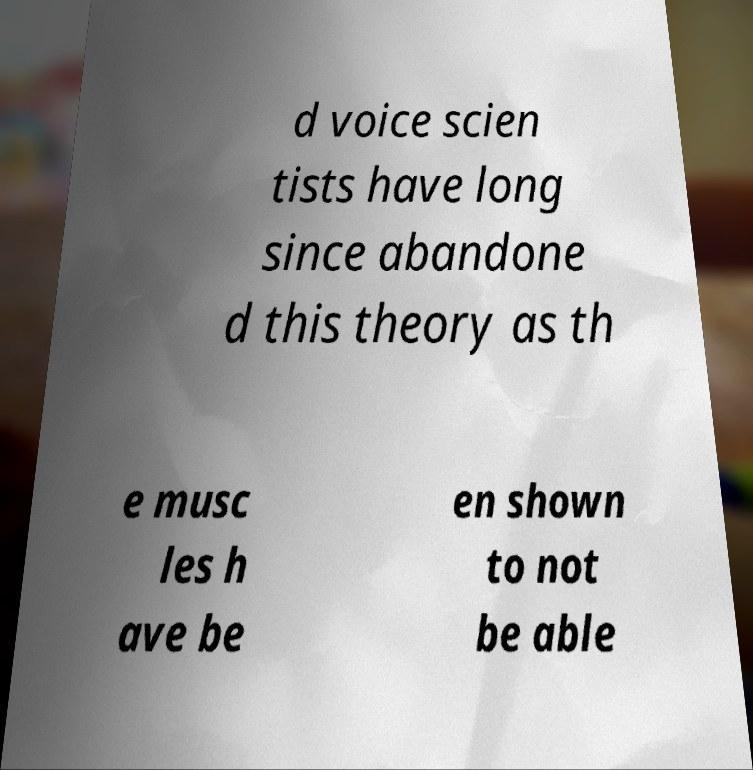Could you assist in decoding the text presented in this image and type it out clearly? d voice scien tists have long since abandone d this theory as th e musc les h ave be en shown to not be able 